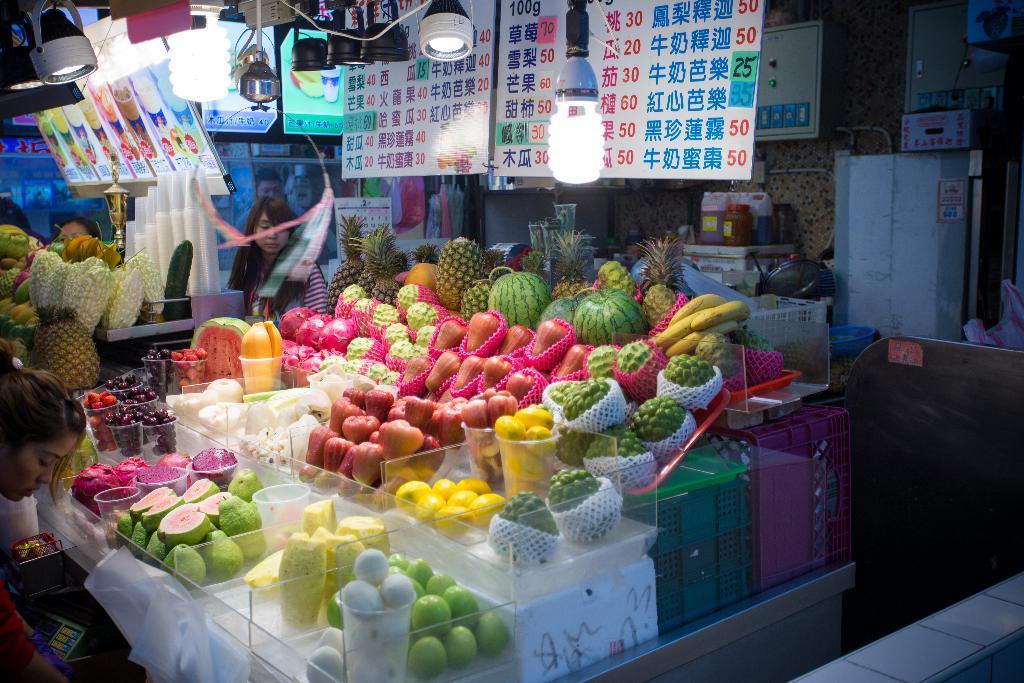In one or two sentences, can you explain what this image depicts? This picture might be taken in a market, in this picture in the center there are different types of fruits and there are some people who are standing and buying fruits. On the top of the image there are some lights and some boards, and in the background there are some containers, bottles and some other objects. 